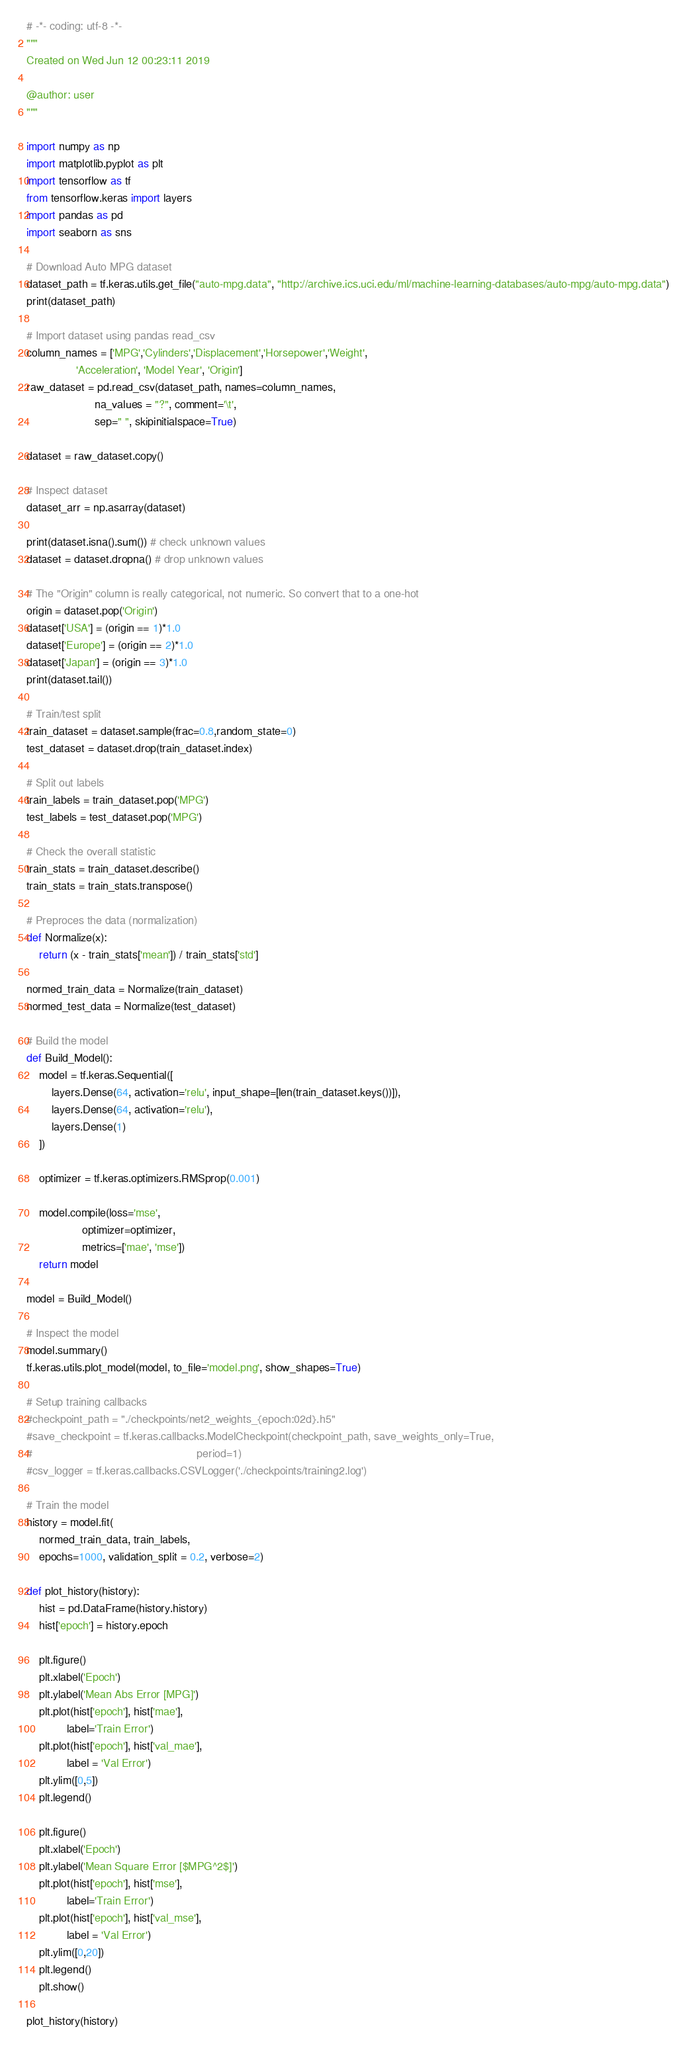<code> <loc_0><loc_0><loc_500><loc_500><_Python_># -*- coding: utf-8 -*-
"""
Created on Wed Jun 12 00:23:11 2019

@author: user
"""

import numpy as np
import matplotlib.pyplot as plt
import tensorflow as tf
from tensorflow.keras import layers
import pandas as pd
import seaborn as sns

# Download Auto MPG dataset
dataset_path = tf.keras.utils.get_file("auto-mpg.data", "http://archive.ics.uci.edu/ml/machine-learning-databases/auto-mpg/auto-mpg.data")
print(dataset_path)

# Import dataset using pandas read_csv
column_names = ['MPG','Cylinders','Displacement','Horsepower','Weight',
                'Acceleration', 'Model Year', 'Origin']
raw_dataset = pd.read_csv(dataset_path, names=column_names,
                      na_values = "?", comment='\t',
                      sep=" ", skipinitialspace=True)

dataset = raw_dataset.copy()

# Inspect dataset
dataset_arr = np.asarray(dataset)

print(dataset.isna().sum()) # check unknown values
dataset = dataset.dropna() # drop unknown values

# The "Origin" column is really categorical, not numeric. So convert that to a one-hot
origin = dataset.pop('Origin')
dataset['USA'] = (origin == 1)*1.0
dataset['Europe'] = (origin == 2)*1.0
dataset['Japan'] = (origin == 3)*1.0
print(dataset.tail())

# Train/test split
train_dataset = dataset.sample(frac=0.8,random_state=0)
test_dataset = dataset.drop(train_dataset.index)

# Split out labels
train_labels = train_dataset.pop('MPG')
test_labels = test_dataset.pop('MPG')

# Check the overall statistic
train_stats = train_dataset.describe()
train_stats = train_stats.transpose()

# Preproces the data (normalization)
def Normalize(x):
    return (x - train_stats['mean']) / train_stats['std']

normed_train_data = Normalize(train_dataset)
normed_test_data = Normalize(test_dataset)

# Build the model
def Build_Model():
    model = tf.keras.Sequential([
        layers.Dense(64, activation='relu', input_shape=[len(train_dataset.keys())]),
        layers.Dense(64, activation='relu'),
        layers.Dense(1)
    ])

    optimizer = tf.keras.optimizers.RMSprop(0.001)

    model.compile(loss='mse',
                  optimizer=optimizer,
                  metrics=['mae', 'mse'])
    return model

model = Build_Model()

# Inspect the model
model.summary()
tf.keras.utils.plot_model(model, to_file='model.png', show_shapes=True)

# Setup training callbacks
#checkpoint_path = "./checkpoints/net2_weights_{epoch:02d}.h5"
#save_checkpoint = tf.keras.callbacks.ModelCheckpoint(checkpoint_path, save_weights_only=True,
#                                                     period=1)
#csv_logger = tf.keras.callbacks.CSVLogger('./checkpoints/training2.log')

# Train the model
history = model.fit(
    normed_train_data, train_labels,
    epochs=1000, validation_split = 0.2, verbose=2)

def plot_history(history):
    hist = pd.DataFrame(history.history)
    hist['epoch'] = history.epoch

    plt.figure()
    plt.xlabel('Epoch')
    plt.ylabel('Mean Abs Error [MPG]')
    plt.plot(hist['epoch'], hist['mae'],
             label='Train Error')
    plt.plot(hist['epoch'], hist['val_mae'],
             label = 'Val Error')
    plt.ylim([0,5])
    plt.legend()

    plt.figure()
    plt.xlabel('Epoch')
    plt.ylabel('Mean Square Error [$MPG^2$]')
    plt.plot(hist['epoch'], hist['mse'],
             label='Train Error')
    plt.plot(hist['epoch'], hist['val_mse'],
             label = 'Val Error')
    plt.ylim([0,20])
    plt.legend()
    plt.show()

plot_history(history)</code> 